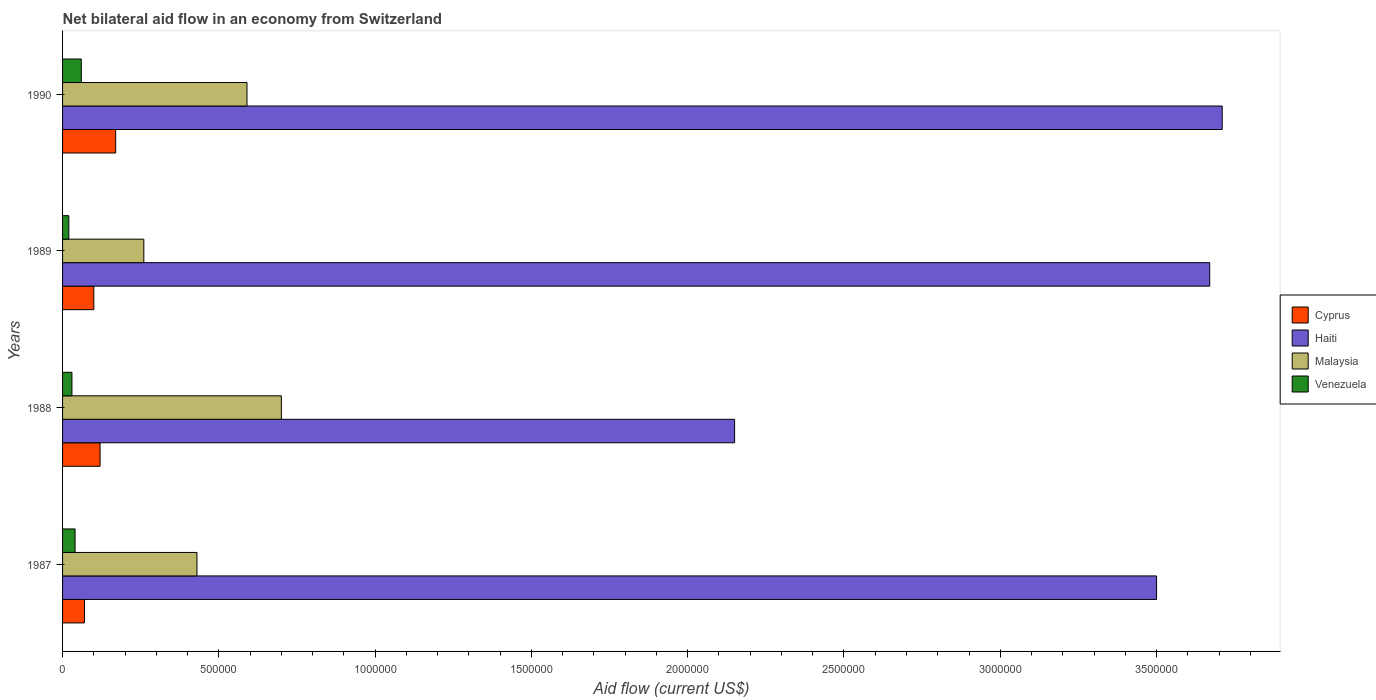How many groups of bars are there?
Keep it short and to the point. 4. Are the number of bars per tick equal to the number of legend labels?
Keep it short and to the point. Yes. Are the number of bars on each tick of the Y-axis equal?
Offer a very short reply. Yes. What is the label of the 2nd group of bars from the top?
Keep it short and to the point. 1989. In how many cases, is the number of bars for a given year not equal to the number of legend labels?
Offer a very short reply. 0. Across all years, what is the maximum net bilateral aid flow in Haiti?
Offer a very short reply. 3.71e+06. Across all years, what is the minimum net bilateral aid flow in Cyprus?
Your response must be concise. 7.00e+04. What is the total net bilateral aid flow in Malaysia in the graph?
Keep it short and to the point. 1.98e+06. What is the difference between the net bilateral aid flow in Haiti in 1987 and that in 1989?
Make the answer very short. -1.70e+05. What is the difference between the net bilateral aid flow in Cyprus in 1987 and the net bilateral aid flow in Venezuela in 1989?
Provide a short and direct response. 5.00e+04. What is the average net bilateral aid flow in Cyprus per year?
Offer a very short reply. 1.15e+05. What is the ratio of the net bilateral aid flow in Haiti in 1989 to that in 1990?
Ensure brevity in your answer.  0.99. What is the difference between the highest and the second highest net bilateral aid flow in Cyprus?
Ensure brevity in your answer.  5.00e+04. What is the difference between the highest and the lowest net bilateral aid flow in Haiti?
Offer a terse response. 1.56e+06. In how many years, is the net bilateral aid flow in Haiti greater than the average net bilateral aid flow in Haiti taken over all years?
Your answer should be compact. 3. Is the sum of the net bilateral aid flow in Malaysia in 1987 and 1989 greater than the maximum net bilateral aid flow in Haiti across all years?
Make the answer very short. No. What does the 3rd bar from the top in 1988 represents?
Your answer should be compact. Haiti. What does the 4th bar from the bottom in 1989 represents?
Ensure brevity in your answer.  Venezuela. How many bars are there?
Provide a succinct answer. 16. How many years are there in the graph?
Your answer should be very brief. 4. What is the difference between two consecutive major ticks on the X-axis?
Keep it short and to the point. 5.00e+05. Are the values on the major ticks of X-axis written in scientific E-notation?
Your answer should be compact. No. Does the graph contain any zero values?
Offer a very short reply. No. Does the graph contain grids?
Keep it short and to the point. No. How many legend labels are there?
Offer a very short reply. 4. How are the legend labels stacked?
Offer a very short reply. Vertical. What is the title of the graph?
Offer a terse response. Net bilateral aid flow in an economy from Switzerland. Does "Uruguay" appear as one of the legend labels in the graph?
Offer a very short reply. No. What is the Aid flow (current US$) of Cyprus in 1987?
Give a very brief answer. 7.00e+04. What is the Aid flow (current US$) in Haiti in 1987?
Offer a very short reply. 3.50e+06. What is the Aid flow (current US$) in Venezuela in 1987?
Keep it short and to the point. 4.00e+04. What is the Aid flow (current US$) of Cyprus in 1988?
Provide a short and direct response. 1.20e+05. What is the Aid flow (current US$) in Haiti in 1988?
Provide a succinct answer. 2.15e+06. What is the Aid flow (current US$) of Venezuela in 1988?
Make the answer very short. 3.00e+04. What is the Aid flow (current US$) in Cyprus in 1989?
Your answer should be very brief. 1.00e+05. What is the Aid flow (current US$) in Haiti in 1989?
Give a very brief answer. 3.67e+06. What is the Aid flow (current US$) of Haiti in 1990?
Offer a terse response. 3.71e+06. What is the Aid flow (current US$) in Malaysia in 1990?
Keep it short and to the point. 5.90e+05. Across all years, what is the maximum Aid flow (current US$) of Haiti?
Offer a very short reply. 3.71e+06. Across all years, what is the maximum Aid flow (current US$) in Malaysia?
Your response must be concise. 7.00e+05. Across all years, what is the maximum Aid flow (current US$) in Venezuela?
Provide a short and direct response. 6.00e+04. Across all years, what is the minimum Aid flow (current US$) of Haiti?
Provide a short and direct response. 2.15e+06. Across all years, what is the minimum Aid flow (current US$) in Malaysia?
Offer a terse response. 2.60e+05. Across all years, what is the minimum Aid flow (current US$) of Venezuela?
Provide a short and direct response. 2.00e+04. What is the total Aid flow (current US$) in Cyprus in the graph?
Your answer should be very brief. 4.60e+05. What is the total Aid flow (current US$) in Haiti in the graph?
Provide a short and direct response. 1.30e+07. What is the total Aid flow (current US$) in Malaysia in the graph?
Your answer should be very brief. 1.98e+06. What is the total Aid flow (current US$) in Venezuela in the graph?
Give a very brief answer. 1.50e+05. What is the difference between the Aid flow (current US$) in Cyprus in 1987 and that in 1988?
Keep it short and to the point. -5.00e+04. What is the difference between the Aid flow (current US$) of Haiti in 1987 and that in 1988?
Provide a short and direct response. 1.35e+06. What is the difference between the Aid flow (current US$) in Haiti in 1987 and that in 1989?
Give a very brief answer. -1.70e+05. What is the difference between the Aid flow (current US$) of Venezuela in 1987 and that in 1989?
Your answer should be compact. 2.00e+04. What is the difference between the Aid flow (current US$) of Malaysia in 1987 and that in 1990?
Ensure brevity in your answer.  -1.60e+05. What is the difference between the Aid flow (current US$) of Haiti in 1988 and that in 1989?
Provide a succinct answer. -1.52e+06. What is the difference between the Aid flow (current US$) in Malaysia in 1988 and that in 1989?
Ensure brevity in your answer.  4.40e+05. What is the difference between the Aid flow (current US$) in Cyprus in 1988 and that in 1990?
Your response must be concise. -5.00e+04. What is the difference between the Aid flow (current US$) in Haiti in 1988 and that in 1990?
Your response must be concise. -1.56e+06. What is the difference between the Aid flow (current US$) of Malaysia in 1988 and that in 1990?
Your response must be concise. 1.10e+05. What is the difference between the Aid flow (current US$) of Cyprus in 1989 and that in 1990?
Provide a short and direct response. -7.00e+04. What is the difference between the Aid flow (current US$) in Malaysia in 1989 and that in 1990?
Keep it short and to the point. -3.30e+05. What is the difference between the Aid flow (current US$) of Venezuela in 1989 and that in 1990?
Make the answer very short. -4.00e+04. What is the difference between the Aid flow (current US$) of Cyprus in 1987 and the Aid flow (current US$) of Haiti in 1988?
Offer a terse response. -2.08e+06. What is the difference between the Aid flow (current US$) of Cyprus in 1987 and the Aid flow (current US$) of Malaysia in 1988?
Your response must be concise. -6.30e+05. What is the difference between the Aid flow (current US$) of Cyprus in 1987 and the Aid flow (current US$) of Venezuela in 1988?
Your answer should be compact. 4.00e+04. What is the difference between the Aid flow (current US$) in Haiti in 1987 and the Aid flow (current US$) in Malaysia in 1988?
Keep it short and to the point. 2.80e+06. What is the difference between the Aid flow (current US$) of Haiti in 1987 and the Aid flow (current US$) of Venezuela in 1988?
Keep it short and to the point. 3.47e+06. What is the difference between the Aid flow (current US$) of Malaysia in 1987 and the Aid flow (current US$) of Venezuela in 1988?
Ensure brevity in your answer.  4.00e+05. What is the difference between the Aid flow (current US$) in Cyprus in 1987 and the Aid flow (current US$) in Haiti in 1989?
Offer a very short reply. -3.60e+06. What is the difference between the Aid flow (current US$) of Haiti in 1987 and the Aid flow (current US$) of Malaysia in 1989?
Your answer should be very brief. 3.24e+06. What is the difference between the Aid flow (current US$) of Haiti in 1987 and the Aid flow (current US$) of Venezuela in 1989?
Give a very brief answer. 3.48e+06. What is the difference between the Aid flow (current US$) of Cyprus in 1987 and the Aid flow (current US$) of Haiti in 1990?
Your answer should be compact. -3.64e+06. What is the difference between the Aid flow (current US$) in Cyprus in 1987 and the Aid flow (current US$) in Malaysia in 1990?
Give a very brief answer. -5.20e+05. What is the difference between the Aid flow (current US$) of Haiti in 1987 and the Aid flow (current US$) of Malaysia in 1990?
Ensure brevity in your answer.  2.91e+06. What is the difference between the Aid flow (current US$) of Haiti in 1987 and the Aid flow (current US$) of Venezuela in 1990?
Make the answer very short. 3.44e+06. What is the difference between the Aid flow (current US$) of Cyprus in 1988 and the Aid flow (current US$) of Haiti in 1989?
Keep it short and to the point. -3.55e+06. What is the difference between the Aid flow (current US$) in Cyprus in 1988 and the Aid flow (current US$) in Venezuela in 1989?
Keep it short and to the point. 1.00e+05. What is the difference between the Aid flow (current US$) in Haiti in 1988 and the Aid flow (current US$) in Malaysia in 1989?
Give a very brief answer. 1.89e+06. What is the difference between the Aid flow (current US$) of Haiti in 1988 and the Aid flow (current US$) of Venezuela in 1989?
Your response must be concise. 2.13e+06. What is the difference between the Aid flow (current US$) of Malaysia in 1988 and the Aid flow (current US$) of Venezuela in 1989?
Provide a succinct answer. 6.80e+05. What is the difference between the Aid flow (current US$) in Cyprus in 1988 and the Aid flow (current US$) in Haiti in 1990?
Offer a terse response. -3.59e+06. What is the difference between the Aid flow (current US$) of Cyprus in 1988 and the Aid flow (current US$) of Malaysia in 1990?
Ensure brevity in your answer.  -4.70e+05. What is the difference between the Aid flow (current US$) of Haiti in 1988 and the Aid flow (current US$) of Malaysia in 1990?
Offer a very short reply. 1.56e+06. What is the difference between the Aid flow (current US$) in Haiti in 1988 and the Aid flow (current US$) in Venezuela in 1990?
Give a very brief answer. 2.09e+06. What is the difference between the Aid flow (current US$) in Malaysia in 1988 and the Aid flow (current US$) in Venezuela in 1990?
Your answer should be compact. 6.40e+05. What is the difference between the Aid flow (current US$) in Cyprus in 1989 and the Aid flow (current US$) in Haiti in 1990?
Give a very brief answer. -3.61e+06. What is the difference between the Aid flow (current US$) in Cyprus in 1989 and the Aid flow (current US$) in Malaysia in 1990?
Your answer should be compact. -4.90e+05. What is the difference between the Aid flow (current US$) of Haiti in 1989 and the Aid flow (current US$) of Malaysia in 1990?
Offer a very short reply. 3.08e+06. What is the difference between the Aid flow (current US$) in Haiti in 1989 and the Aid flow (current US$) in Venezuela in 1990?
Your answer should be compact. 3.61e+06. What is the average Aid flow (current US$) in Cyprus per year?
Your answer should be very brief. 1.15e+05. What is the average Aid flow (current US$) in Haiti per year?
Ensure brevity in your answer.  3.26e+06. What is the average Aid flow (current US$) in Malaysia per year?
Provide a short and direct response. 4.95e+05. What is the average Aid flow (current US$) in Venezuela per year?
Keep it short and to the point. 3.75e+04. In the year 1987, what is the difference between the Aid flow (current US$) of Cyprus and Aid flow (current US$) of Haiti?
Give a very brief answer. -3.43e+06. In the year 1987, what is the difference between the Aid flow (current US$) of Cyprus and Aid flow (current US$) of Malaysia?
Offer a very short reply. -3.60e+05. In the year 1987, what is the difference between the Aid flow (current US$) in Haiti and Aid flow (current US$) in Malaysia?
Offer a very short reply. 3.07e+06. In the year 1987, what is the difference between the Aid flow (current US$) of Haiti and Aid flow (current US$) of Venezuela?
Your answer should be very brief. 3.46e+06. In the year 1987, what is the difference between the Aid flow (current US$) in Malaysia and Aid flow (current US$) in Venezuela?
Your answer should be very brief. 3.90e+05. In the year 1988, what is the difference between the Aid flow (current US$) of Cyprus and Aid flow (current US$) of Haiti?
Offer a very short reply. -2.03e+06. In the year 1988, what is the difference between the Aid flow (current US$) of Cyprus and Aid flow (current US$) of Malaysia?
Your answer should be very brief. -5.80e+05. In the year 1988, what is the difference between the Aid flow (current US$) of Cyprus and Aid flow (current US$) of Venezuela?
Your answer should be compact. 9.00e+04. In the year 1988, what is the difference between the Aid flow (current US$) of Haiti and Aid flow (current US$) of Malaysia?
Offer a terse response. 1.45e+06. In the year 1988, what is the difference between the Aid flow (current US$) of Haiti and Aid flow (current US$) of Venezuela?
Your answer should be compact. 2.12e+06. In the year 1988, what is the difference between the Aid flow (current US$) of Malaysia and Aid flow (current US$) of Venezuela?
Offer a very short reply. 6.70e+05. In the year 1989, what is the difference between the Aid flow (current US$) in Cyprus and Aid flow (current US$) in Haiti?
Your answer should be very brief. -3.57e+06. In the year 1989, what is the difference between the Aid flow (current US$) of Cyprus and Aid flow (current US$) of Venezuela?
Your answer should be compact. 8.00e+04. In the year 1989, what is the difference between the Aid flow (current US$) in Haiti and Aid flow (current US$) in Malaysia?
Give a very brief answer. 3.41e+06. In the year 1989, what is the difference between the Aid flow (current US$) of Haiti and Aid flow (current US$) of Venezuela?
Your answer should be compact. 3.65e+06. In the year 1990, what is the difference between the Aid flow (current US$) of Cyprus and Aid flow (current US$) of Haiti?
Offer a terse response. -3.54e+06. In the year 1990, what is the difference between the Aid flow (current US$) of Cyprus and Aid flow (current US$) of Malaysia?
Offer a very short reply. -4.20e+05. In the year 1990, what is the difference between the Aid flow (current US$) in Cyprus and Aid flow (current US$) in Venezuela?
Offer a very short reply. 1.10e+05. In the year 1990, what is the difference between the Aid flow (current US$) in Haiti and Aid flow (current US$) in Malaysia?
Keep it short and to the point. 3.12e+06. In the year 1990, what is the difference between the Aid flow (current US$) of Haiti and Aid flow (current US$) of Venezuela?
Keep it short and to the point. 3.65e+06. In the year 1990, what is the difference between the Aid flow (current US$) in Malaysia and Aid flow (current US$) in Venezuela?
Provide a succinct answer. 5.30e+05. What is the ratio of the Aid flow (current US$) in Cyprus in 1987 to that in 1988?
Ensure brevity in your answer.  0.58. What is the ratio of the Aid flow (current US$) in Haiti in 1987 to that in 1988?
Your answer should be very brief. 1.63. What is the ratio of the Aid flow (current US$) of Malaysia in 1987 to that in 1988?
Offer a very short reply. 0.61. What is the ratio of the Aid flow (current US$) in Haiti in 1987 to that in 1989?
Your answer should be very brief. 0.95. What is the ratio of the Aid flow (current US$) in Malaysia in 1987 to that in 1989?
Give a very brief answer. 1.65. What is the ratio of the Aid flow (current US$) in Venezuela in 1987 to that in 1989?
Make the answer very short. 2. What is the ratio of the Aid flow (current US$) of Cyprus in 1987 to that in 1990?
Make the answer very short. 0.41. What is the ratio of the Aid flow (current US$) in Haiti in 1987 to that in 1990?
Ensure brevity in your answer.  0.94. What is the ratio of the Aid flow (current US$) of Malaysia in 1987 to that in 1990?
Ensure brevity in your answer.  0.73. What is the ratio of the Aid flow (current US$) in Venezuela in 1987 to that in 1990?
Keep it short and to the point. 0.67. What is the ratio of the Aid flow (current US$) of Haiti in 1988 to that in 1989?
Give a very brief answer. 0.59. What is the ratio of the Aid flow (current US$) in Malaysia in 1988 to that in 1989?
Keep it short and to the point. 2.69. What is the ratio of the Aid flow (current US$) in Venezuela in 1988 to that in 1989?
Your response must be concise. 1.5. What is the ratio of the Aid flow (current US$) in Cyprus in 1988 to that in 1990?
Make the answer very short. 0.71. What is the ratio of the Aid flow (current US$) of Haiti in 1988 to that in 1990?
Provide a succinct answer. 0.58. What is the ratio of the Aid flow (current US$) in Malaysia in 1988 to that in 1990?
Give a very brief answer. 1.19. What is the ratio of the Aid flow (current US$) of Cyprus in 1989 to that in 1990?
Offer a terse response. 0.59. What is the ratio of the Aid flow (current US$) in Haiti in 1989 to that in 1990?
Your answer should be compact. 0.99. What is the ratio of the Aid flow (current US$) of Malaysia in 1989 to that in 1990?
Offer a terse response. 0.44. What is the ratio of the Aid flow (current US$) of Venezuela in 1989 to that in 1990?
Make the answer very short. 0.33. What is the difference between the highest and the second highest Aid flow (current US$) in Cyprus?
Offer a very short reply. 5.00e+04. What is the difference between the highest and the second highest Aid flow (current US$) in Haiti?
Ensure brevity in your answer.  4.00e+04. What is the difference between the highest and the second highest Aid flow (current US$) of Venezuela?
Keep it short and to the point. 2.00e+04. What is the difference between the highest and the lowest Aid flow (current US$) of Cyprus?
Your answer should be very brief. 1.00e+05. What is the difference between the highest and the lowest Aid flow (current US$) of Haiti?
Provide a succinct answer. 1.56e+06. What is the difference between the highest and the lowest Aid flow (current US$) in Malaysia?
Your answer should be very brief. 4.40e+05. What is the difference between the highest and the lowest Aid flow (current US$) of Venezuela?
Make the answer very short. 4.00e+04. 